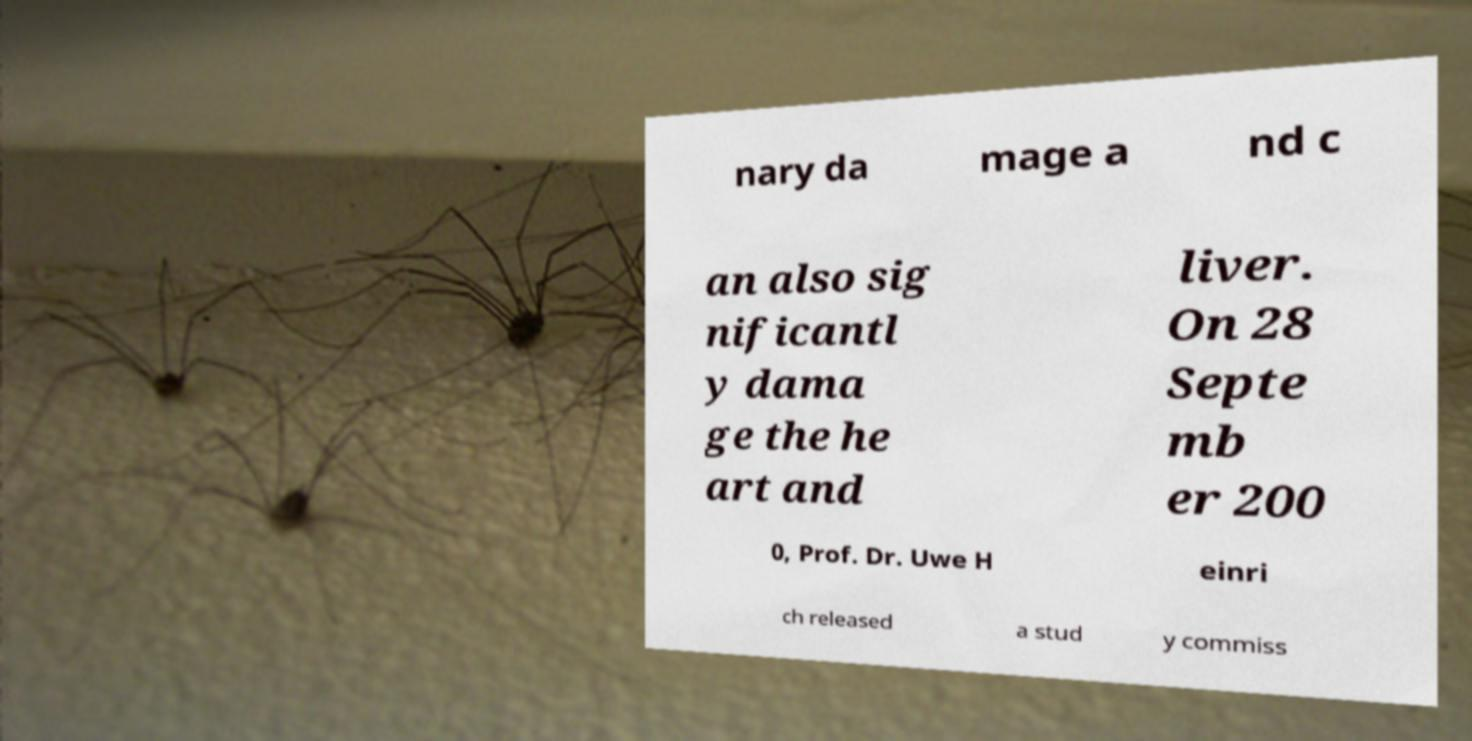Could you assist in decoding the text presented in this image and type it out clearly? nary da mage a nd c an also sig nificantl y dama ge the he art and liver. On 28 Septe mb er 200 0, Prof. Dr. Uwe H einri ch released a stud y commiss 